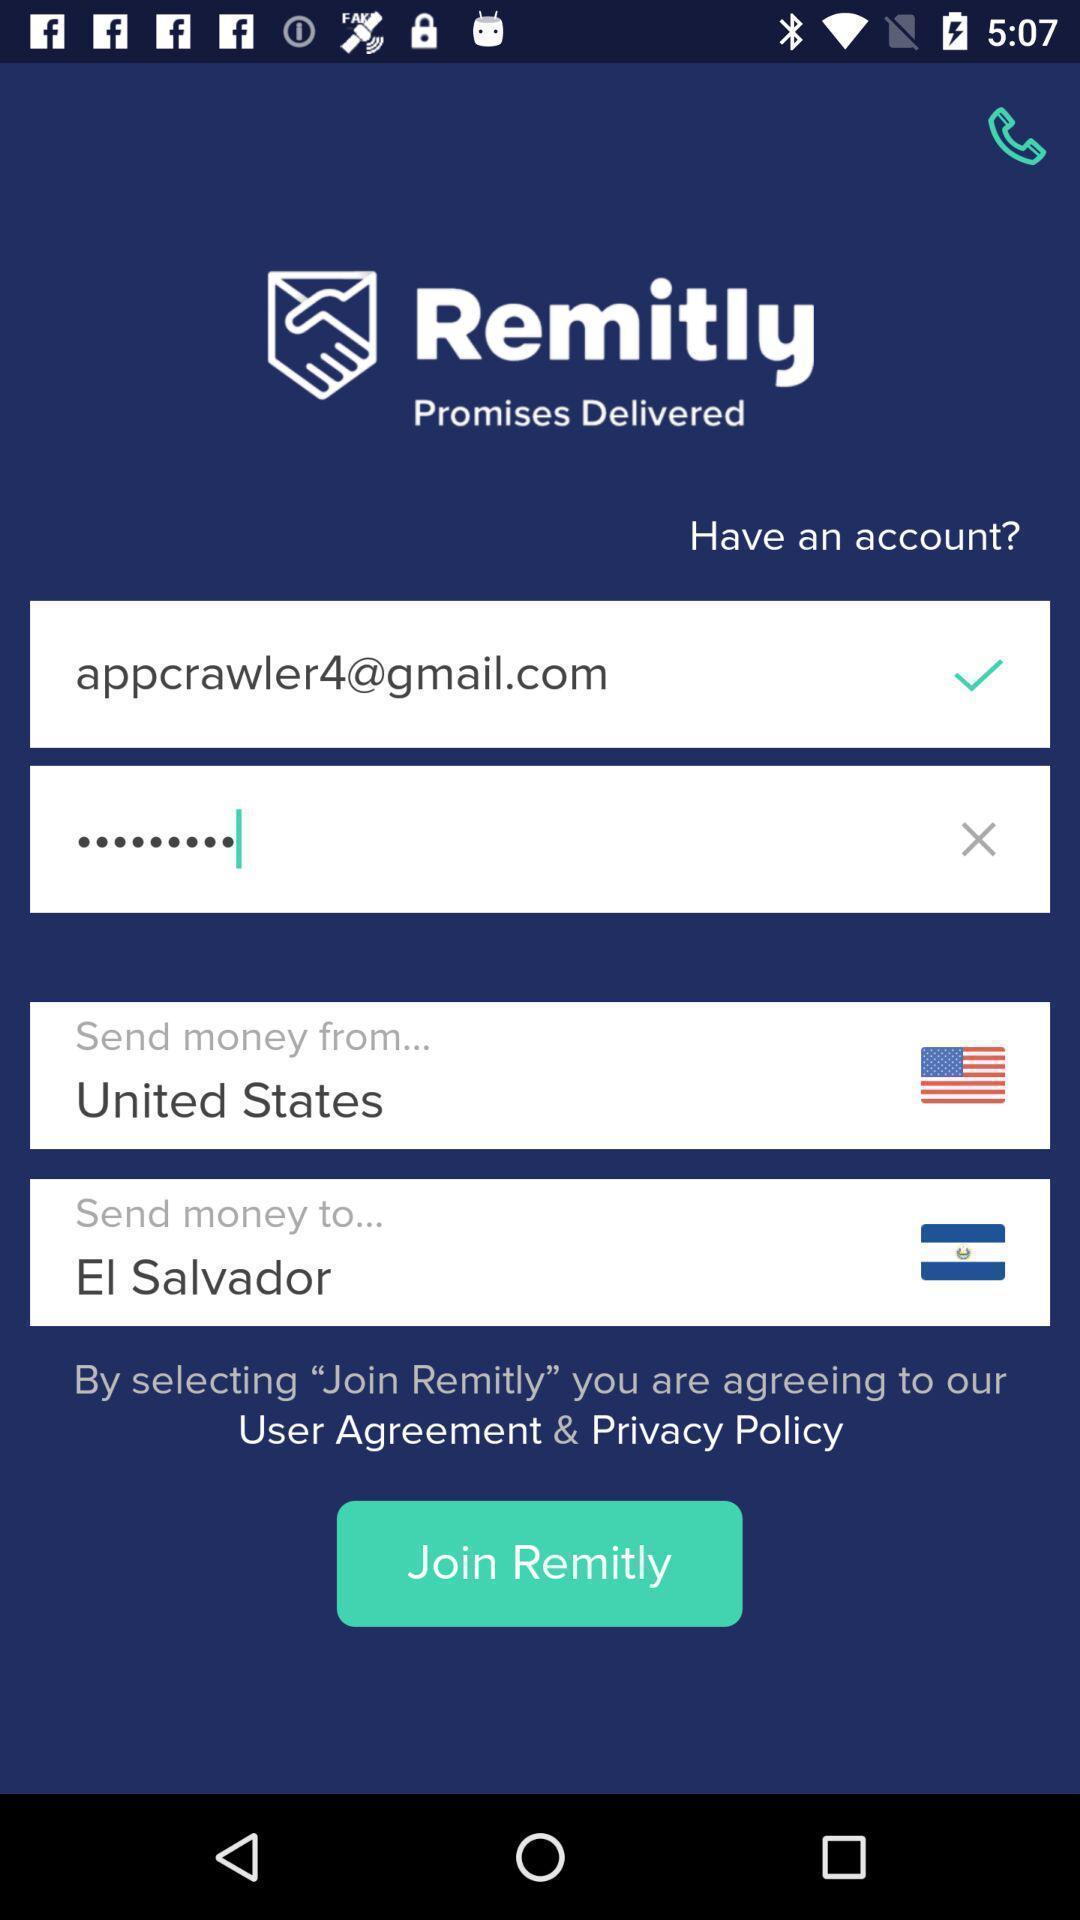Explain the elements present in this screenshot. Screen showing page. 